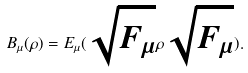<formula> <loc_0><loc_0><loc_500><loc_500>B _ { \mu } ( \rho ) = E _ { \mu } ( \sqrt { F _ { \mu } } \rho \sqrt { F _ { \mu } } ) .</formula> 